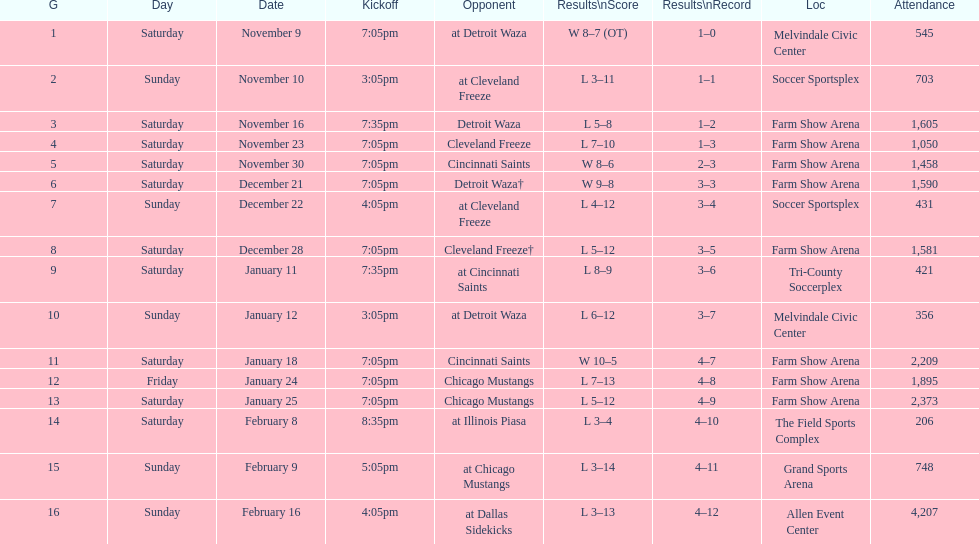What was the location before tri-county soccerplex? Farm Show Arena. 